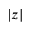Convert formula to latex. <formula><loc_0><loc_0><loc_500><loc_500>| z |</formula> 